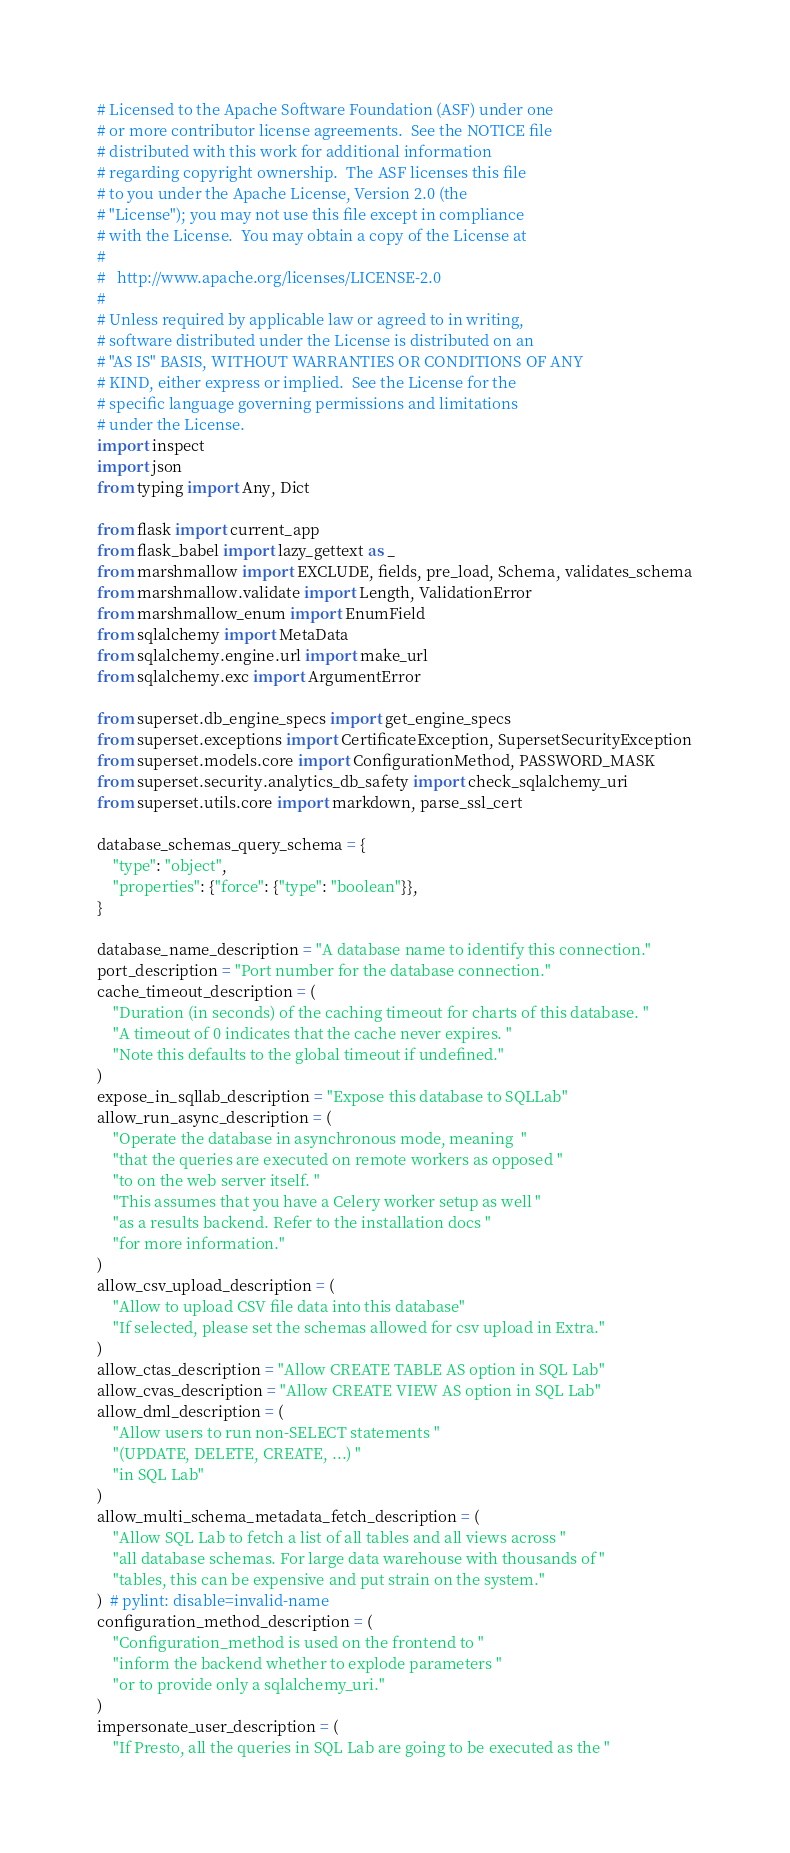Convert code to text. <code><loc_0><loc_0><loc_500><loc_500><_Python_># Licensed to the Apache Software Foundation (ASF) under one
# or more contributor license agreements.  See the NOTICE file
# distributed with this work for additional information
# regarding copyright ownership.  The ASF licenses this file
# to you under the Apache License, Version 2.0 (the
# "License"); you may not use this file except in compliance
# with the License.  You may obtain a copy of the License at
#
#   http://www.apache.org/licenses/LICENSE-2.0
#
# Unless required by applicable law or agreed to in writing,
# software distributed under the License is distributed on an
# "AS IS" BASIS, WITHOUT WARRANTIES OR CONDITIONS OF ANY
# KIND, either express or implied.  See the License for the
# specific language governing permissions and limitations
# under the License.
import inspect
import json
from typing import Any, Dict

from flask import current_app
from flask_babel import lazy_gettext as _
from marshmallow import EXCLUDE, fields, pre_load, Schema, validates_schema
from marshmallow.validate import Length, ValidationError
from marshmallow_enum import EnumField
from sqlalchemy import MetaData
from sqlalchemy.engine.url import make_url
from sqlalchemy.exc import ArgumentError

from superset.db_engine_specs import get_engine_specs
from superset.exceptions import CertificateException, SupersetSecurityException
from superset.models.core import ConfigurationMethod, PASSWORD_MASK
from superset.security.analytics_db_safety import check_sqlalchemy_uri
from superset.utils.core import markdown, parse_ssl_cert

database_schemas_query_schema = {
    "type": "object",
    "properties": {"force": {"type": "boolean"}},
}

database_name_description = "A database name to identify this connection."
port_description = "Port number for the database connection."
cache_timeout_description = (
    "Duration (in seconds) of the caching timeout for charts of this database. "
    "A timeout of 0 indicates that the cache never expires. "
    "Note this defaults to the global timeout if undefined."
)
expose_in_sqllab_description = "Expose this database to SQLLab"
allow_run_async_description = (
    "Operate the database in asynchronous mode, meaning  "
    "that the queries are executed on remote workers as opposed "
    "to on the web server itself. "
    "This assumes that you have a Celery worker setup as well "
    "as a results backend. Refer to the installation docs "
    "for more information."
)
allow_csv_upload_description = (
    "Allow to upload CSV file data into this database"
    "If selected, please set the schemas allowed for csv upload in Extra."
)
allow_ctas_description = "Allow CREATE TABLE AS option in SQL Lab"
allow_cvas_description = "Allow CREATE VIEW AS option in SQL Lab"
allow_dml_description = (
    "Allow users to run non-SELECT statements "
    "(UPDATE, DELETE, CREATE, ...) "
    "in SQL Lab"
)
allow_multi_schema_metadata_fetch_description = (
    "Allow SQL Lab to fetch a list of all tables and all views across "
    "all database schemas. For large data warehouse with thousands of "
    "tables, this can be expensive and put strain on the system."
)  # pylint: disable=invalid-name
configuration_method_description = (
    "Configuration_method is used on the frontend to "
    "inform the backend whether to explode parameters "
    "or to provide only a sqlalchemy_uri."
)
impersonate_user_description = (
    "If Presto, all the queries in SQL Lab are going to be executed as the "</code> 